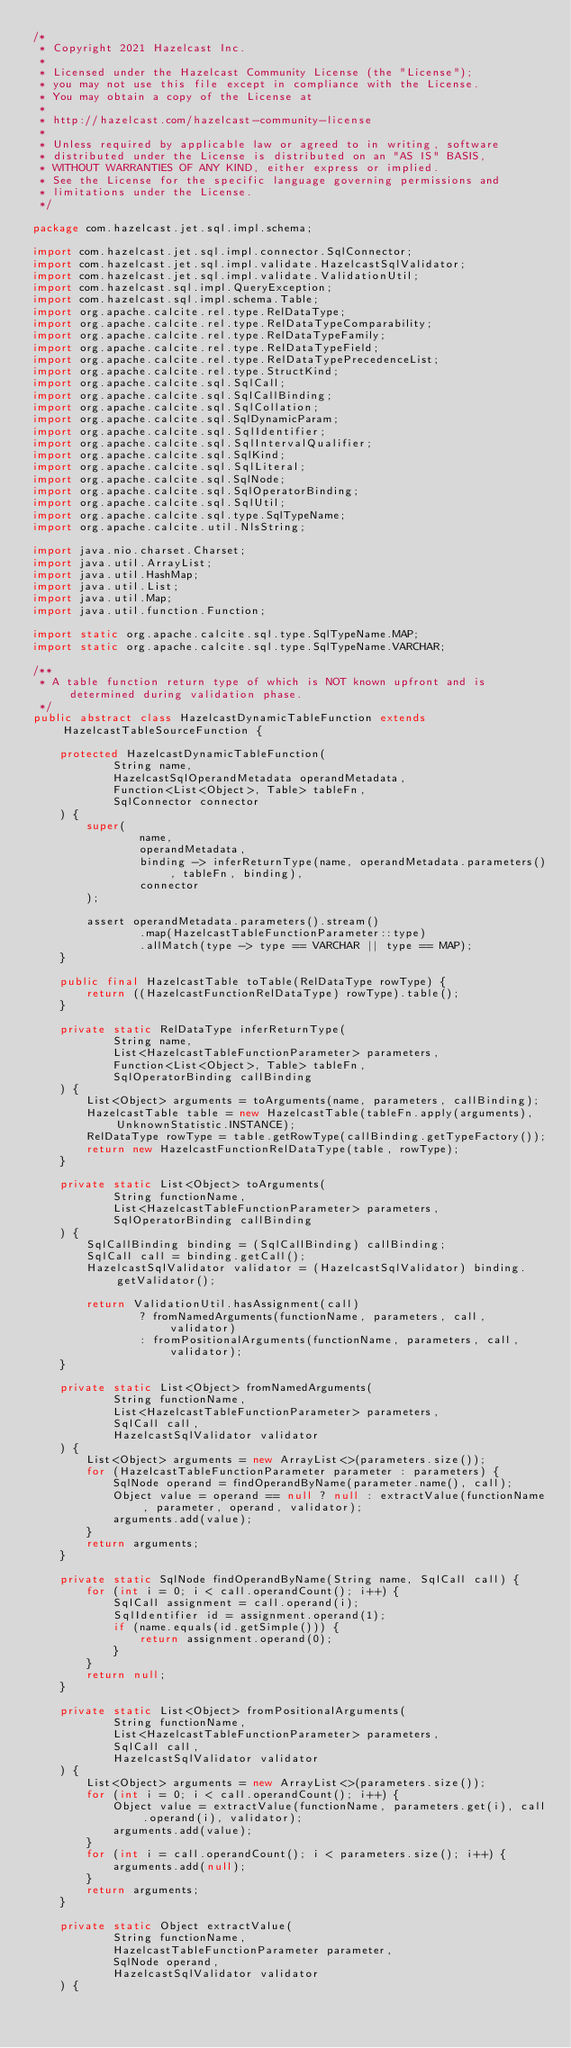Convert code to text. <code><loc_0><loc_0><loc_500><loc_500><_Java_>/*
 * Copyright 2021 Hazelcast Inc.
 *
 * Licensed under the Hazelcast Community License (the "License");
 * you may not use this file except in compliance with the License.
 * You may obtain a copy of the License at
 *
 * http://hazelcast.com/hazelcast-community-license
 *
 * Unless required by applicable law or agreed to in writing, software
 * distributed under the License is distributed on an "AS IS" BASIS,
 * WITHOUT WARRANTIES OF ANY KIND, either express or implied.
 * See the License for the specific language governing permissions and
 * limitations under the License.
 */

package com.hazelcast.jet.sql.impl.schema;

import com.hazelcast.jet.sql.impl.connector.SqlConnector;
import com.hazelcast.jet.sql.impl.validate.HazelcastSqlValidator;
import com.hazelcast.jet.sql.impl.validate.ValidationUtil;
import com.hazelcast.sql.impl.QueryException;
import com.hazelcast.sql.impl.schema.Table;
import org.apache.calcite.rel.type.RelDataType;
import org.apache.calcite.rel.type.RelDataTypeComparability;
import org.apache.calcite.rel.type.RelDataTypeFamily;
import org.apache.calcite.rel.type.RelDataTypeField;
import org.apache.calcite.rel.type.RelDataTypePrecedenceList;
import org.apache.calcite.rel.type.StructKind;
import org.apache.calcite.sql.SqlCall;
import org.apache.calcite.sql.SqlCallBinding;
import org.apache.calcite.sql.SqlCollation;
import org.apache.calcite.sql.SqlDynamicParam;
import org.apache.calcite.sql.SqlIdentifier;
import org.apache.calcite.sql.SqlIntervalQualifier;
import org.apache.calcite.sql.SqlKind;
import org.apache.calcite.sql.SqlLiteral;
import org.apache.calcite.sql.SqlNode;
import org.apache.calcite.sql.SqlOperatorBinding;
import org.apache.calcite.sql.SqlUtil;
import org.apache.calcite.sql.type.SqlTypeName;
import org.apache.calcite.util.NlsString;

import java.nio.charset.Charset;
import java.util.ArrayList;
import java.util.HashMap;
import java.util.List;
import java.util.Map;
import java.util.function.Function;

import static org.apache.calcite.sql.type.SqlTypeName.MAP;
import static org.apache.calcite.sql.type.SqlTypeName.VARCHAR;

/**
 * A table function return type of which is NOT known upfront and is determined during validation phase.
 */
public abstract class HazelcastDynamicTableFunction extends HazelcastTableSourceFunction {

    protected HazelcastDynamicTableFunction(
            String name,
            HazelcastSqlOperandMetadata operandMetadata,
            Function<List<Object>, Table> tableFn,
            SqlConnector connector
    ) {
        super(
                name,
                operandMetadata,
                binding -> inferReturnType(name, operandMetadata.parameters(), tableFn, binding),
                connector
        );

        assert operandMetadata.parameters().stream()
                .map(HazelcastTableFunctionParameter::type)
                .allMatch(type -> type == VARCHAR || type == MAP);
    }

    public final HazelcastTable toTable(RelDataType rowType) {
        return ((HazelcastFunctionRelDataType) rowType).table();
    }

    private static RelDataType inferReturnType(
            String name,
            List<HazelcastTableFunctionParameter> parameters,
            Function<List<Object>, Table> tableFn,
            SqlOperatorBinding callBinding
    ) {
        List<Object> arguments = toArguments(name, parameters, callBinding);
        HazelcastTable table = new HazelcastTable(tableFn.apply(arguments), UnknownStatistic.INSTANCE);
        RelDataType rowType = table.getRowType(callBinding.getTypeFactory());
        return new HazelcastFunctionRelDataType(table, rowType);
    }

    private static List<Object> toArguments(
            String functionName,
            List<HazelcastTableFunctionParameter> parameters,
            SqlOperatorBinding callBinding
    ) {
        SqlCallBinding binding = (SqlCallBinding) callBinding;
        SqlCall call = binding.getCall();
        HazelcastSqlValidator validator = (HazelcastSqlValidator) binding.getValidator();

        return ValidationUtil.hasAssignment(call)
                ? fromNamedArguments(functionName, parameters, call, validator)
                : fromPositionalArguments(functionName, parameters, call, validator);
    }

    private static List<Object> fromNamedArguments(
            String functionName,
            List<HazelcastTableFunctionParameter> parameters,
            SqlCall call,
            HazelcastSqlValidator validator
    ) {
        List<Object> arguments = new ArrayList<>(parameters.size());
        for (HazelcastTableFunctionParameter parameter : parameters) {
            SqlNode operand = findOperandByName(parameter.name(), call);
            Object value = operand == null ? null : extractValue(functionName, parameter, operand, validator);
            arguments.add(value);
        }
        return arguments;
    }

    private static SqlNode findOperandByName(String name, SqlCall call) {
        for (int i = 0; i < call.operandCount(); i++) {
            SqlCall assignment = call.operand(i);
            SqlIdentifier id = assignment.operand(1);
            if (name.equals(id.getSimple())) {
                return assignment.operand(0);
            }
        }
        return null;
    }

    private static List<Object> fromPositionalArguments(
            String functionName,
            List<HazelcastTableFunctionParameter> parameters,
            SqlCall call,
            HazelcastSqlValidator validator
    ) {
        List<Object> arguments = new ArrayList<>(parameters.size());
        for (int i = 0; i < call.operandCount(); i++) {
            Object value = extractValue(functionName, parameters.get(i), call.operand(i), validator);
            arguments.add(value);
        }
        for (int i = call.operandCount(); i < parameters.size(); i++) {
            arguments.add(null);
        }
        return arguments;
    }

    private static Object extractValue(
            String functionName,
            HazelcastTableFunctionParameter parameter,
            SqlNode operand,
            HazelcastSqlValidator validator
    ) {</code> 